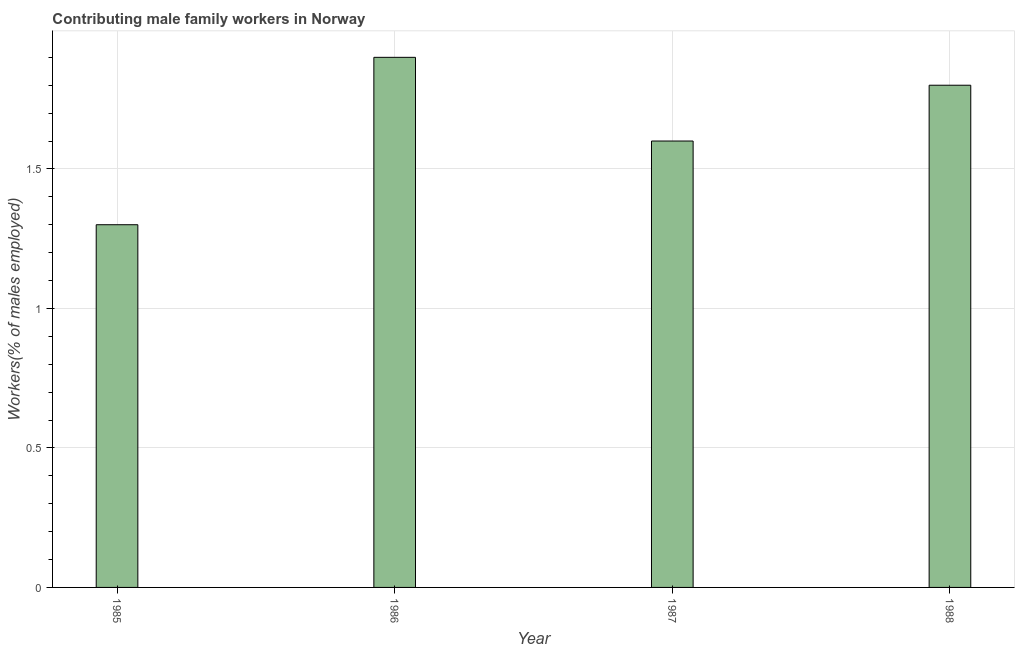Does the graph contain any zero values?
Your answer should be very brief. No. Does the graph contain grids?
Ensure brevity in your answer.  Yes. What is the title of the graph?
Keep it short and to the point. Contributing male family workers in Norway. What is the label or title of the X-axis?
Offer a very short reply. Year. What is the label or title of the Y-axis?
Offer a very short reply. Workers(% of males employed). What is the contributing male family workers in 1987?
Offer a very short reply. 1.6. Across all years, what is the maximum contributing male family workers?
Give a very brief answer. 1.9. Across all years, what is the minimum contributing male family workers?
Your response must be concise. 1.3. What is the sum of the contributing male family workers?
Make the answer very short. 6.6. What is the difference between the contributing male family workers in 1985 and 1986?
Make the answer very short. -0.6. What is the average contributing male family workers per year?
Provide a succinct answer. 1.65. What is the median contributing male family workers?
Provide a succinct answer. 1.7. In how many years, is the contributing male family workers greater than 0.8 %?
Provide a short and direct response. 4. What is the ratio of the contributing male family workers in 1987 to that in 1988?
Provide a short and direct response. 0.89. Is the contributing male family workers in 1986 less than that in 1988?
Make the answer very short. No. How many bars are there?
Make the answer very short. 4. Are all the bars in the graph horizontal?
Provide a succinct answer. No. What is the Workers(% of males employed) of 1985?
Provide a short and direct response. 1.3. What is the Workers(% of males employed) in 1986?
Provide a short and direct response. 1.9. What is the Workers(% of males employed) of 1987?
Provide a succinct answer. 1.6. What is the Workers(% of males employed) in 1988?
Your response must be concise. 1.8. What is the difference between the Workers(% of males employed) in 1985 and 1988?
Give a very brief answer. -0.5. What is the difference between the Workers(% of males employed) in 1986 and 1987?
Provide a short and direct response. 0.3. What is the ratio of the Workers(% of males employed) in 1985 to that in 1986?
Provide a short and direct response. 0.68. What is the ratio of the Workers(% of males employed) in 1985 to that in 1987?
Offer a terse response. 0.81. What is the ratio of the Workers(% of males employed) in 1985 to that in 1988?
Provide a succinct answer. 0.72. What is the ratio of the Workers(% of males employed) in 1986 to that in 1987?
Your answer should be very brief. 1.19. What is the ratio of the Workers(% of males employed) in 1986 to that in 1988?
Your response must be concise. 1.06. What is the ratio of the Workers(% of males employed) in 1987 to that in 1988?
Give a very brief answer. 0.89. 